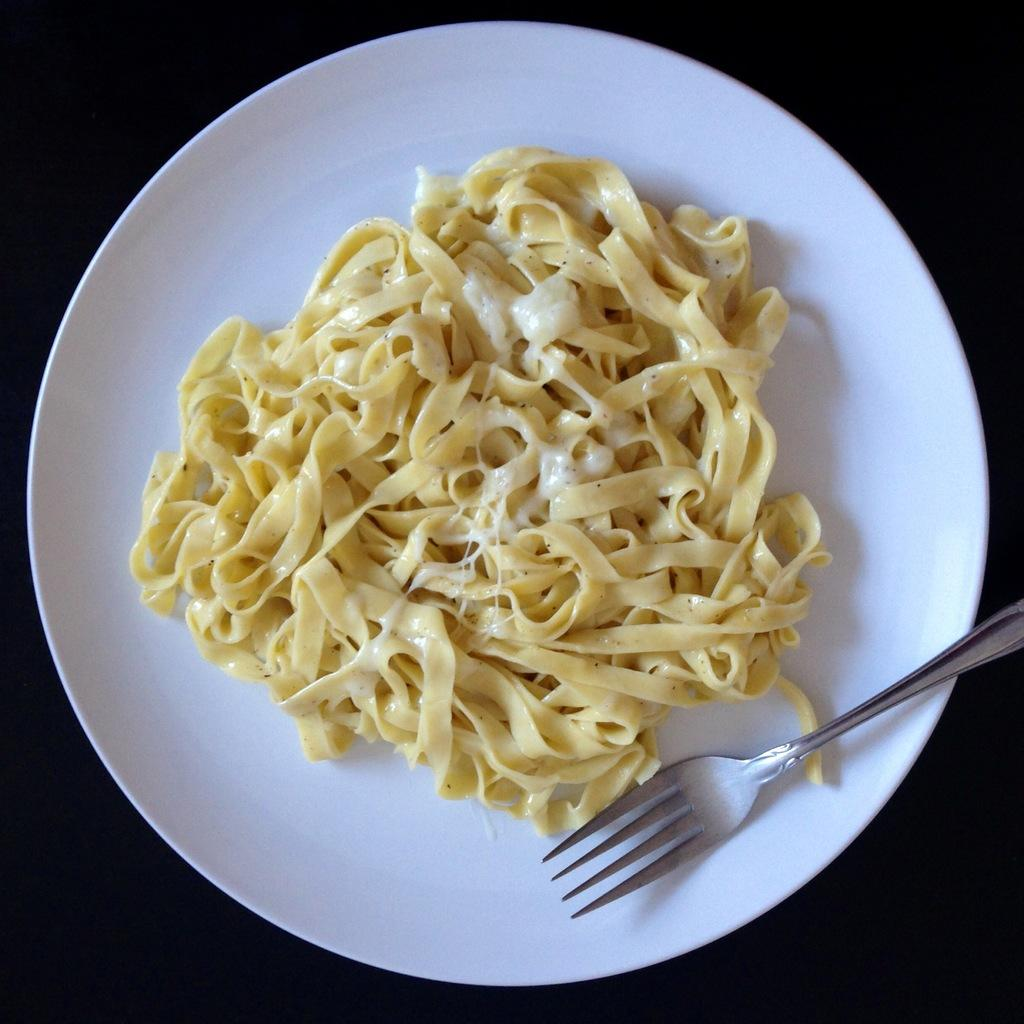What type of food can be seen in the image? The image contains food, but the specific type is not mentioned. What utensil is placed on the white plate? There is a fork on a white plate in the image. What color is the background of the image? The background of the image is black. What type of feast is being prepared in the image? There is no indication of a feast or any preparation in the image; it only shows food, a fork, and a white plate on a black background. How can the fork be washed in the image? There is no visible sink or washing station in the image, so it is not possible to assume that the fork cannot be washed in the image. 